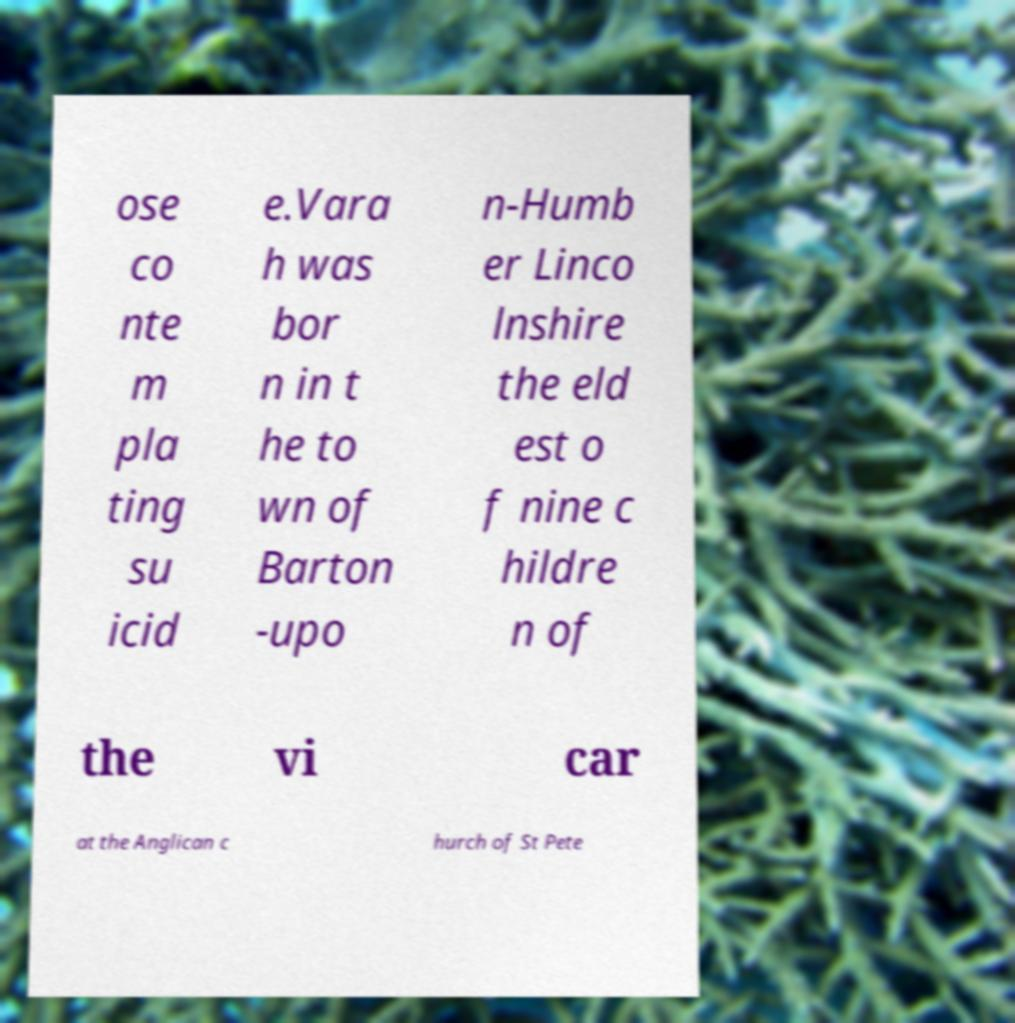Please read and relay the text visible in this image. What does it say? ose co nte m pla ting su icid e.Vara h was bor n in t he to wn of Barton -upo n-Humb er Linco lnshire the eld est o f nine c hildre n of the vi car at the Anglican c hurch of St Pete 